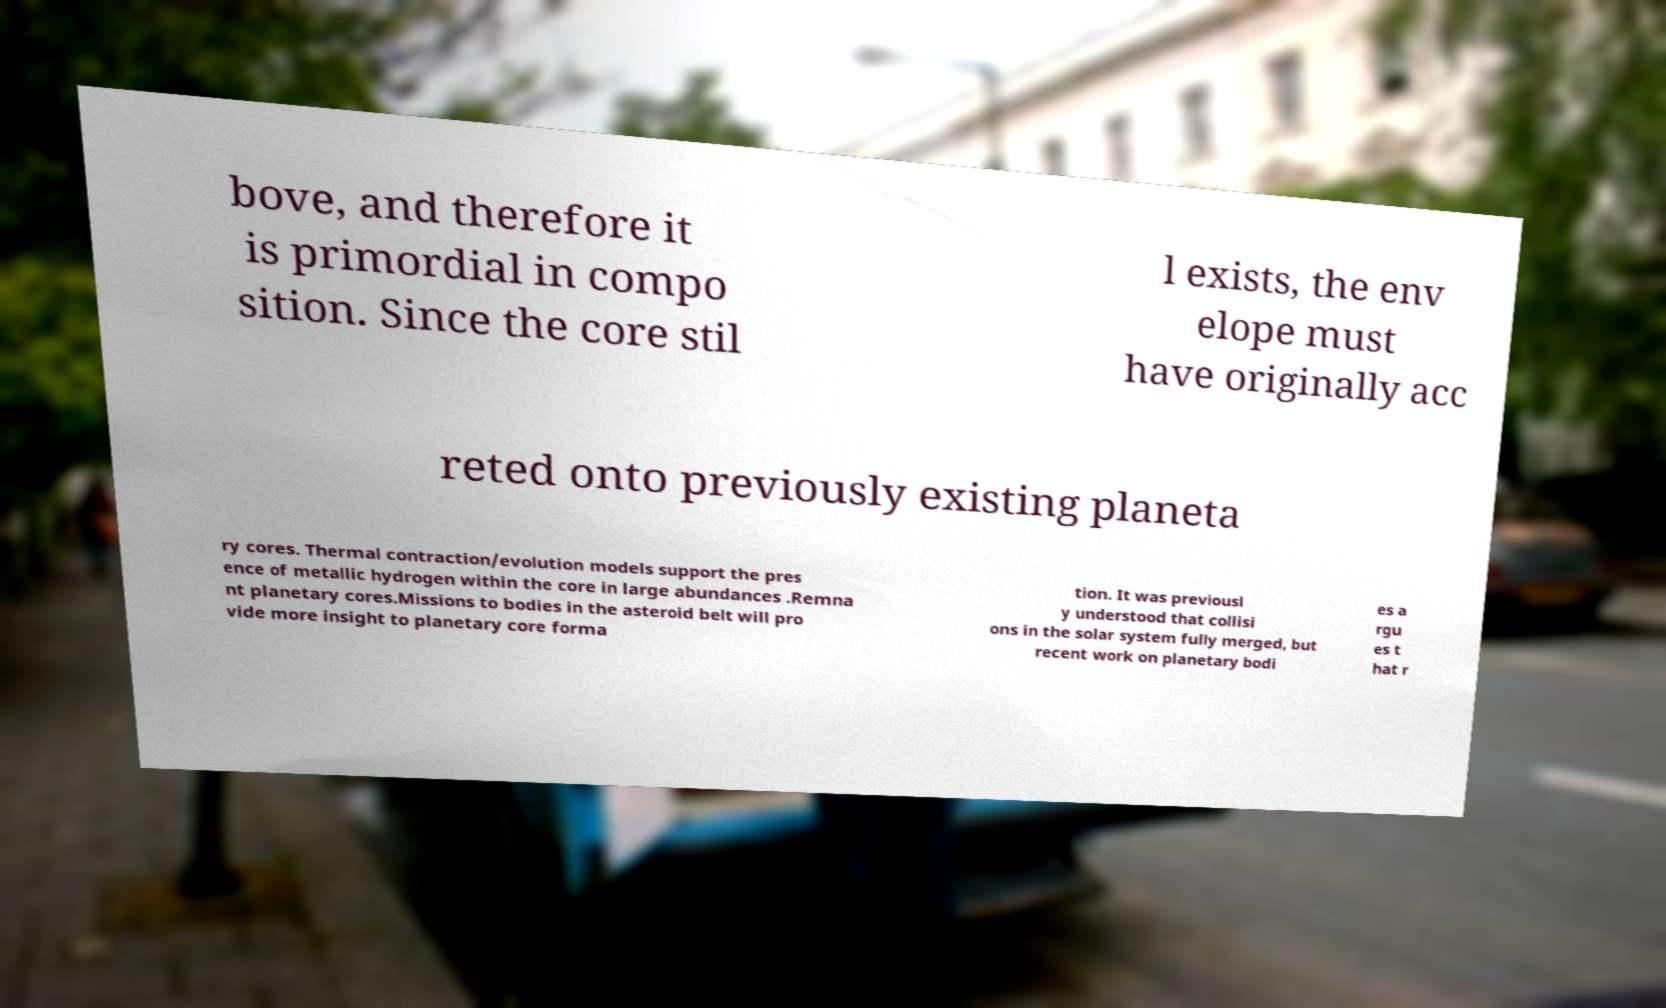There's text embedded in this image that I need extracted. Can you transcribe it verbatim? bove, and therefore it is primordial in compo sition. Since the core stil l exists, the env elope must have originally acc reted onto previously existing planeta ry cores. Thermal contraction/evolution models support the pres ence of metallic hydrogen within the core in large abundances .Remna nt planetary cores.Missions to bodies in the asteroid belt will pro vide more insight to planetary core forma tion. It was previousl y understood that collisi ons in the solar system fully merged, but recent work on planetary bodi es a rgu es t hat r 